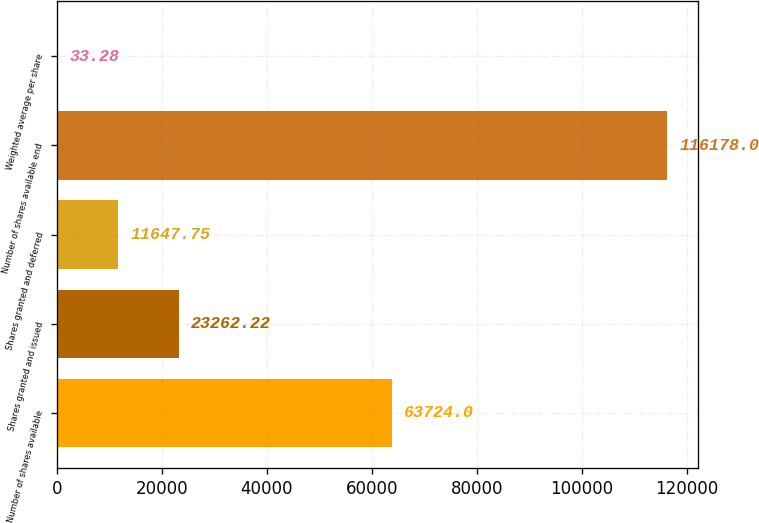Convert chart. <chart><loc_0><loc_0><loc_500><loc_500><bar_chart><fcel>Number of shares available<fcel>Shares granted and issued<fcel>Shares granted and deferred<fcel>Number of shares available end<fcel>Weighted average per share<nl><fcel>63724<fcel>23262.2<fcel>11647.8<fcel>116178<fcel>33.28<nl></chart> 